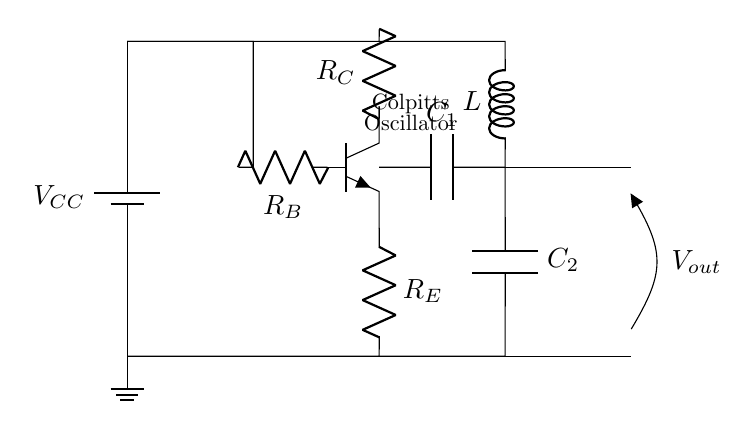What type of transistor is used in this oscillator? The transistor used in the circuit is an NPN transistor, which can be identified by the symbol in the diagram and the labeling typically used for bipolar junction transistors.
Answer: NPN What are the values of the capacitors in the circuit? The circuit diagram shows two capacitors, labeled C1 and C2. However, their specific values are not provided in the diagram, so you would need to refer to a separate component list or specifications for that information.
Answer: Not specified How many resistors are present in the circuit? There are three resistors labeled R_C, R_B, and R_E in the circuit diagram. Counting each of these gives a total of three resistors in the Colpitts oscillator design.
Answer: Three What is the purpose of the inductor in the oscillator? The inductor labeled L in the circuit is essential for creating oscillations. It works in combination with the capacitors to form a resonant circuit, which is critical in generating the oscillatory output necessary for an oscillator.
Answer: Resonance What is the output voltage of the Colpitts oscillator? The output voltage V_out is indicated on the circuit diagram. However, the specific value of this voltage depends on the configuration and components in use, which are not detailed in the diagram.
Answer: Not specified In which applications is this Colpitts oscillator typically used? Colpitts oscillators are commonly used in AM radio transmitters for local broadcasting due to their capability of generating stable oscillation frequencies. This makes them suitable for frequency modulation in communications.
Answer: AM radio transmitters What is the role of R_B in the Colpitts oscillator? R_B serves as a base resistor that controls the base current to the transistor, which is crucial for determining the transistor's operating point and ensuring proper amplification in the oscillator circuit.
Answer: Controls base current 